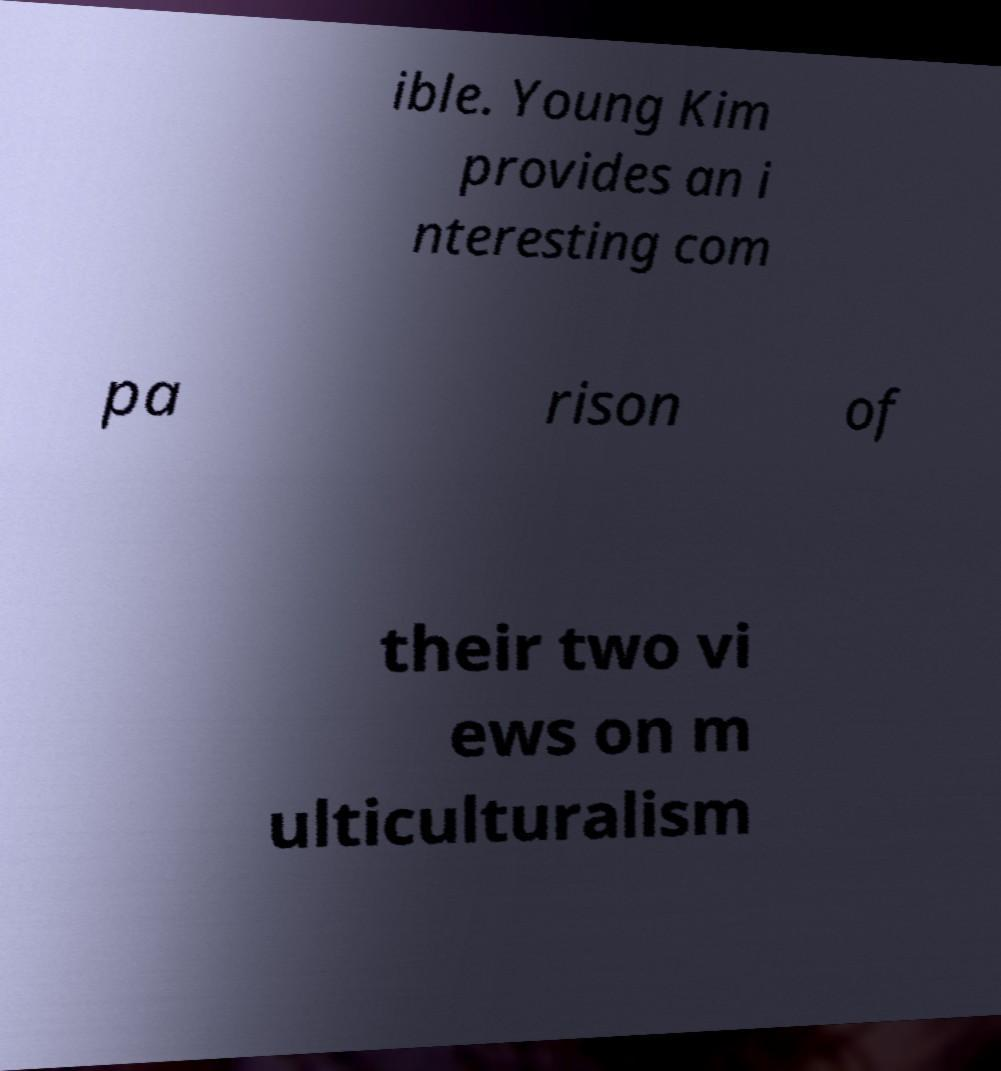What messages or text are displayed in this image? I need them in a readable, typed format. ible. Young Kim provides an i nteresting com pa rison of their two vi ews on m ulticulturalism 